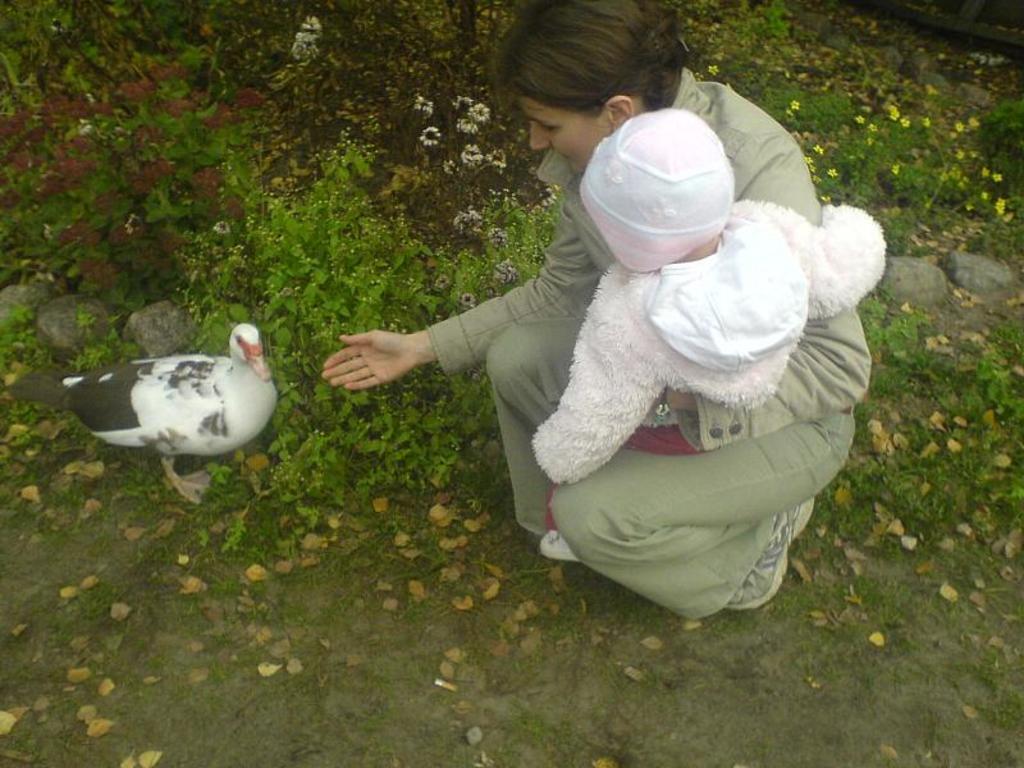Describe this image in one or two sentences. In this image we can see one person and a child. And we can see a bird. And we can see the surrounding stones, flowers and plants. 